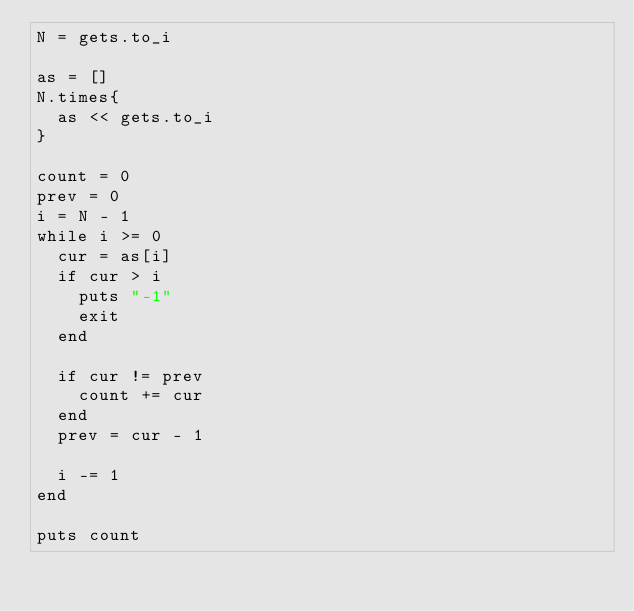Convert code to text. <code><loc_0><loc_0><loc_500><loc_500><_Ruby_>N = gets.to_i

as = []
N.times{
	as << gets.to_i
}

count = 0
prev = 0
i = N - 1
while i >= 0
	cur = as[i]
	if cur > i
		puts "-1"
		exit
	end
	
	if cur != prev
		count += cur
	end
	prev = cur - 1
	
	i -= 1
end

puts count

</code> 